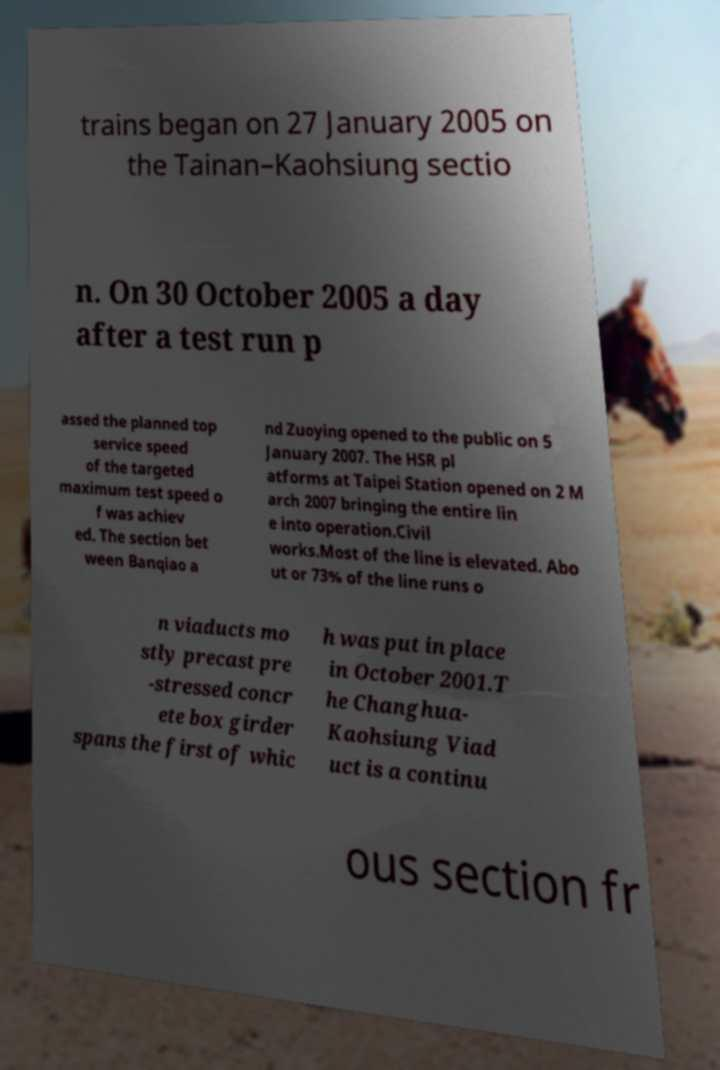Could you extract and type out the text from this image? trains began on 27 January 2005 on the Tainan–Kaohsiung sectio n. On 30 October 2005 a day after a test run p assed the planned top service speed of the targeted maximum test speed o f was achiev ed. The section bet ween Banqiao a nd Zuoying opened to the public on 5 January 2007. The HSR pl atforms at Taipei Station opened on 2 M arch 2007 bringing the entire lin e into operation.Civil works.Most of the line is elevated. Abo ut or 73% of the line runs o n viaducts mo stly precast pre -stressed concr ete box girder spans the first of whic h was put in place in October 2001.T he Changhua- Kaohsiung Viad uct is a continu ous section fr 